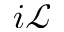<formula> <loc_0><loc_0><loc_500><loc_500>i \mathcal { L }</formula> 